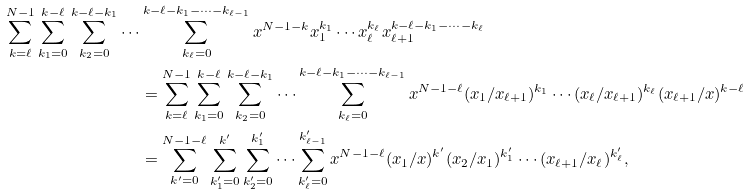<formula> <loc_0><loc_0><loc_500><loc_500>\sum _ { k = \ell } ^ { N - 1 } \sum _ { k _ { 1 } = 0 } ^ { k - \ell } \sum _ { k _ { 2 } = 0 } ^ { k - \ell - k _ { 1 } } \cdots & \sum _ { k _ { \ell } = 0 } ^ { k - \ell - k _ { 1 } - \cdots - k _ { \ell - 1 } } x ^ { N - 1 - k } x _ { 1 } ^ { k _ { 1 } } \cdots x _ { \ell } ^ { k _ { \ell } } x _ { \ell + 1 } ^ { k - \ell - k _ { 1 } - \cdots - k _ { \ell } } \\ & = \sum _ { k = \ell } ^ { N - 1 } \sum _ { k _ { 1 } = 0 } ^ { k - \ell } \sum _ { k _ { 2 } = 0 } ^ { k - \ell - k _ { 1 } } \cdots \sum _ { k _ { \ell } = 0 } ^ { k - \ell - k _ { 1 } - \cdots - k _ { \ell - 1 } } x ^ { N - 1 - \ell } ( x _ { 1 } / x _ { \ell + 1 } ) ^ { k _ { 1 } } \cdots ( x _ { \ell } / x _ { \ell + 1 } ) ^ { k _ { \ell } } ( x _ { \ell + 1 } / x ) ^ { k - \ell } \\ & = \sum _ { k ^ { \prime } = 0 } ^ { N - 1 - \ell } \sum _ { k _ { 1 } ^ { \prime } = 0 } ^ { k ^ { \prime } } \sum _ { k _ { 2 } ^ { \prime } = 0 } ^ { k _ { 1 } ^ { \prime } } \cdots \sum _ { k _ { \ell } ^ { \prime } = 0 } ^ { k _ { \ell - 1 } ^ { \prime } } x ^ { N - 1 - \ell } ( x _ { 1 } / x ) ^ { k ^ { \prime } } ( x _ { 2 } / x _ { 1 } ) ^ { k _ { 1 } ^ { \prime } } \cdots ( x _ { \ell + 1 } / x _ { \ell } ) ^ { k _ { \ell } ^ { \prime } } ,</formula> 